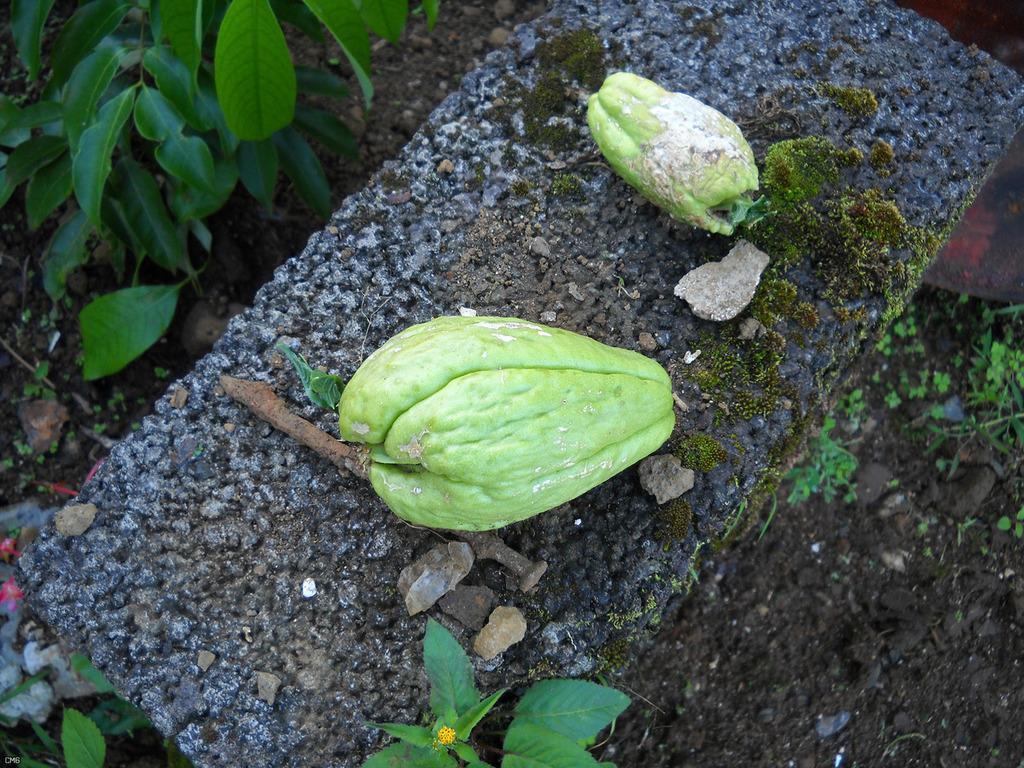Could you give a brief overview of what you see in this image? In this picture, it seems like fruits on a stone, there are stones and plants. 